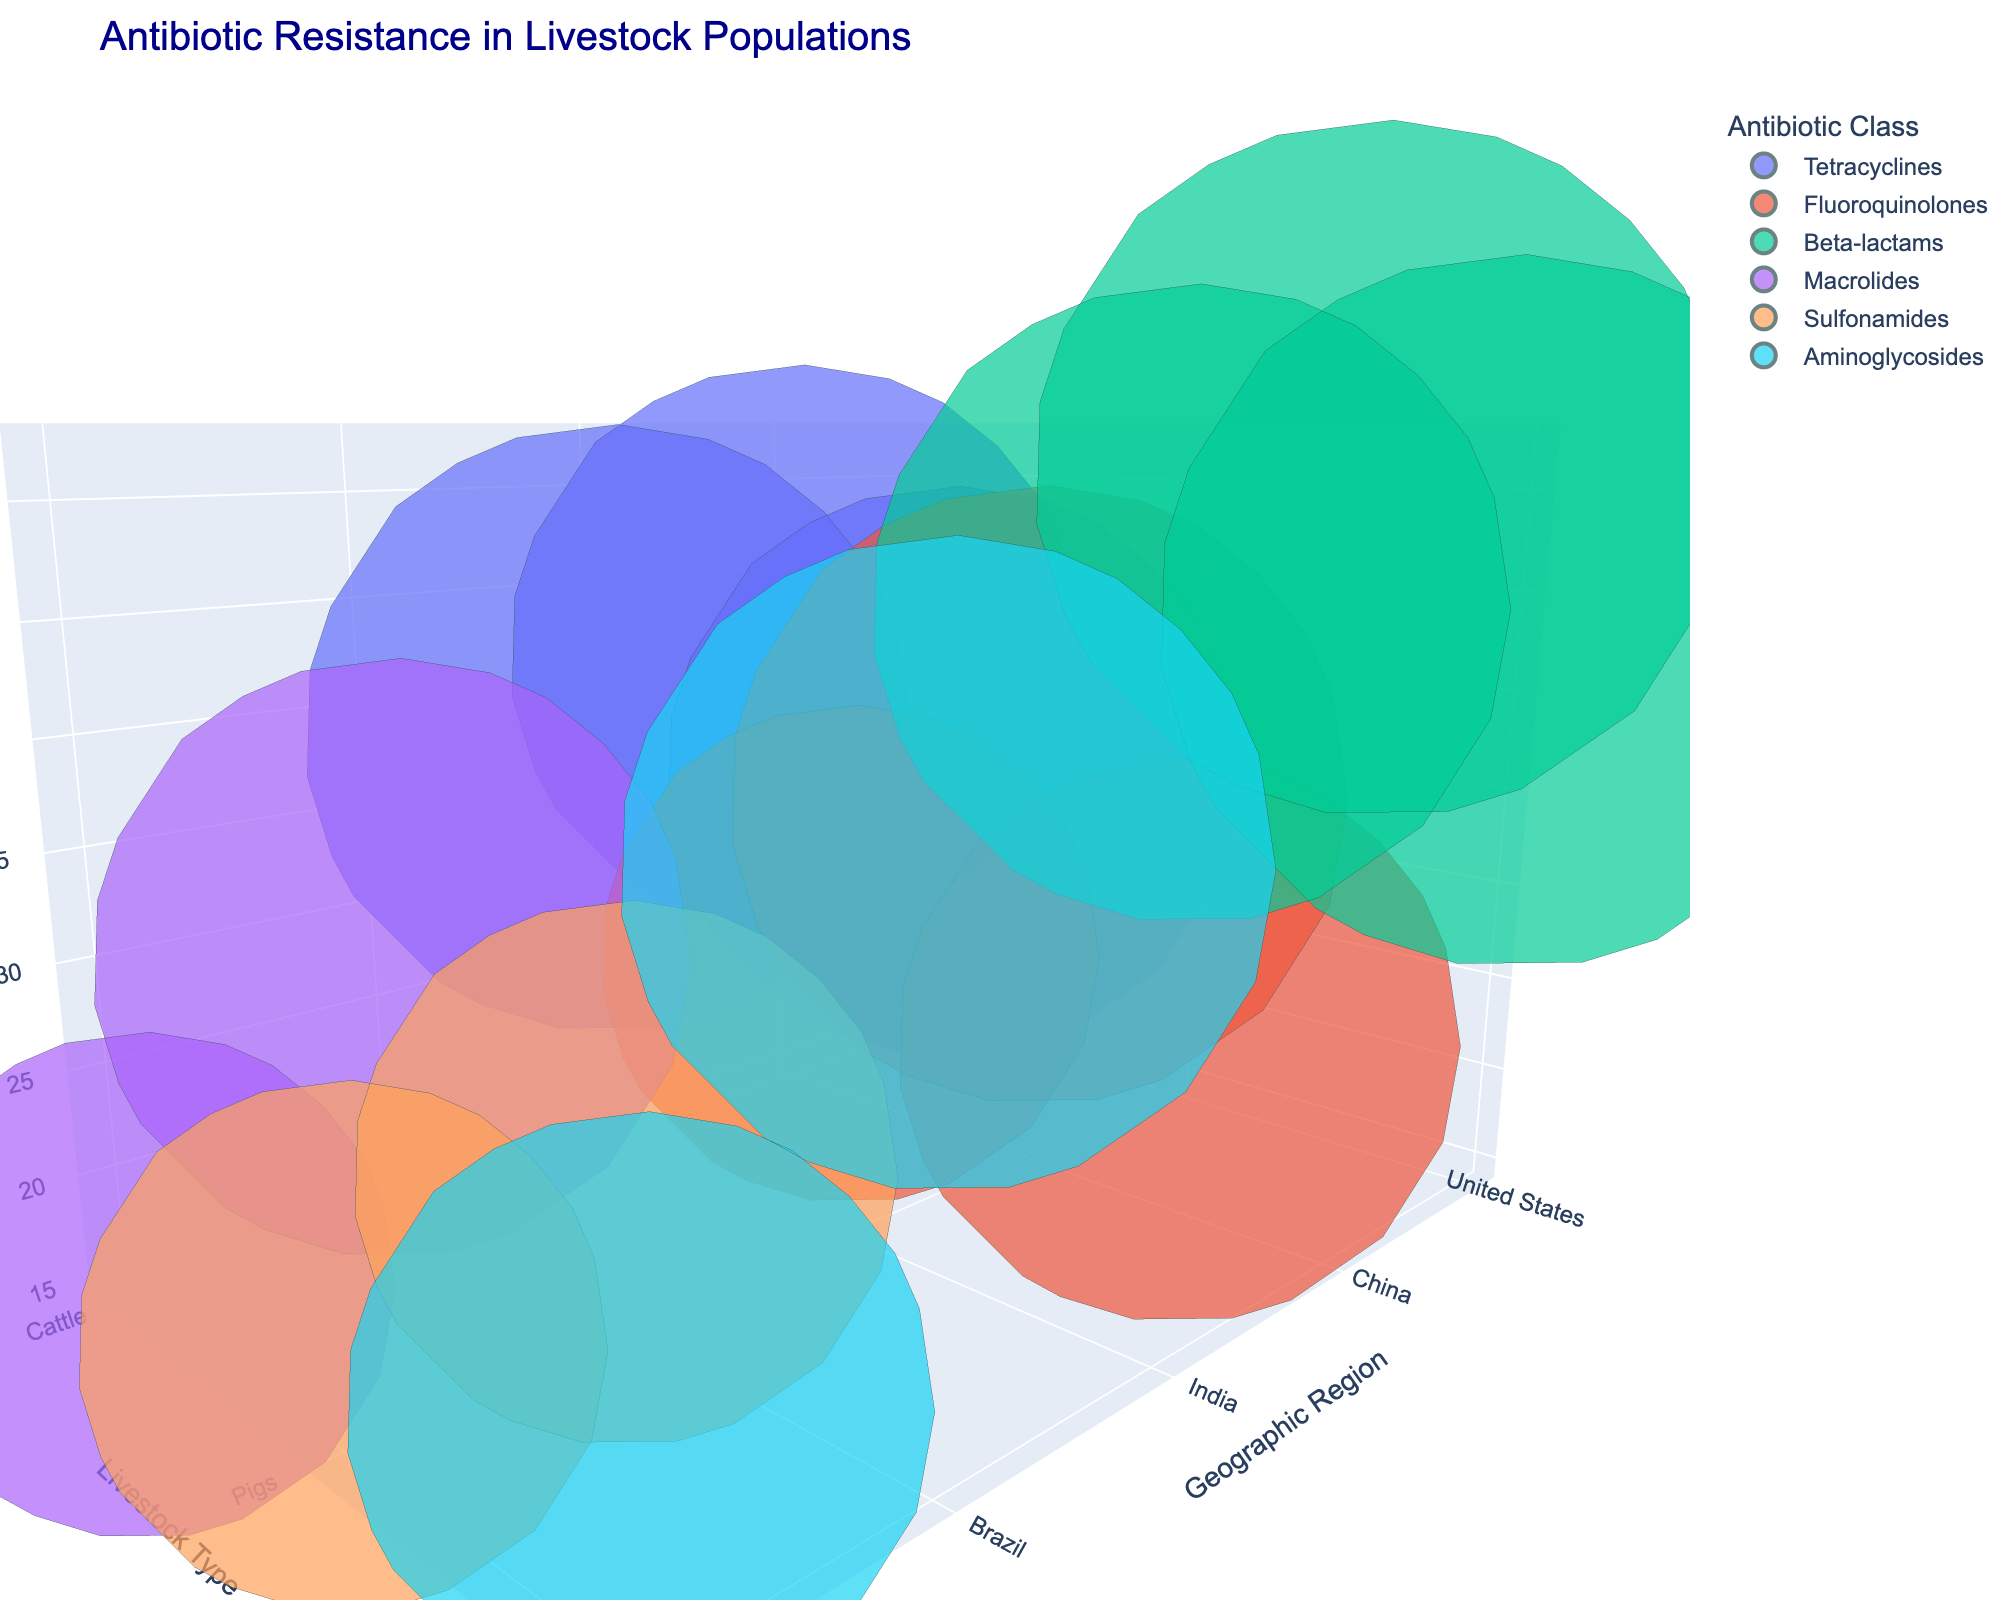What's the title of the plot? The title of the plot is typically located at the top of the chart. In this case, it reads "Antibiotic Resistance in Livestock Populations".
Answer: Antibiotic Resistance in Livestock Populations What are the axis labels? The axis labels provide information on what each axis represents. Here, the x-axis is labeled 'Geographic Region', the y-axis is labeled 'Livestock Type', and the z-axis is labeled 'Resistance (%)'.
Answer: Geographic Region, Livestock Type, Resistance (%) Which antibiotic class has the highest resistance prevalence in China? By examining the 3D plot and focusing on China's data points, we see that 'Beta-lactams' has the highest resistance prevalence at 52%.
Answer: Beta-lactams What are the colors representing in the chart? The legend on the chart indicates that the colors represent different antibiotic classes.
Answer: Antibiotic classes Which livestock type in the United States has the highest population size? By inspecting the bubble sizes (which are proportional to population size) for the United States, the largest bubble is for 'Chickens' with a population of 9,200,000,000.
Answer: Chickens How do the resistance prevalence values for Tetracyclines in cattle compare between the United States, China, and India? We compare the bubbles labeled with 'Tetracyclines' for cattle in these regions. The resistance prevalences are 32% (United States), 41% (China), and 38% (India). Thus, China has the highest, followed by India, and then the United States.
Answer: 32% (US), 41% (China), 38% (India) In which geographic region is the resistance prevalence for 'Sulfonamides' in pigs the lowest? By inspecting the bubbles corresponding to 'Sulfonamides' for pigs and comparing their z-axis values (resistance prevalence), Germany has the lowest at 19%, when compared to Brazil's 22%.
Answer: Germany What is the sum of the resistance prevalences for 'Fluoroquinolones' across all countries? Add the resistance prevalences for 'Fluoroquinolones' in the United States (18%), China (35%), and India (29%). The sum is 18 + 35 + 29 = 82%.
Answer: 82% Which antibiotic class is the most prevalent in terms of resistance for chickens in Brazil? By examining the data points for chickens in Brazil, we see that 'Aminoglycosides' has a resistance prevalence of 39%, which is the highest.
Answer: Aminoglycosides What is the normalized population size for 'Cattle' in the United States? The normalized population size is calculated as log10(population) * 5. For cattle in the United States with a population of 94,000,000, we find log10(94000000) ≈ 7.97, then 7.97 * 5 ≈ 39.85.
Answer: 39.85 